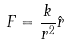Convert formula to latex. <formula><loc_0><loc_0><loc_500><loc_500>F = \frac { k } { r ^ { 2 } } \hat { r }</formula> 